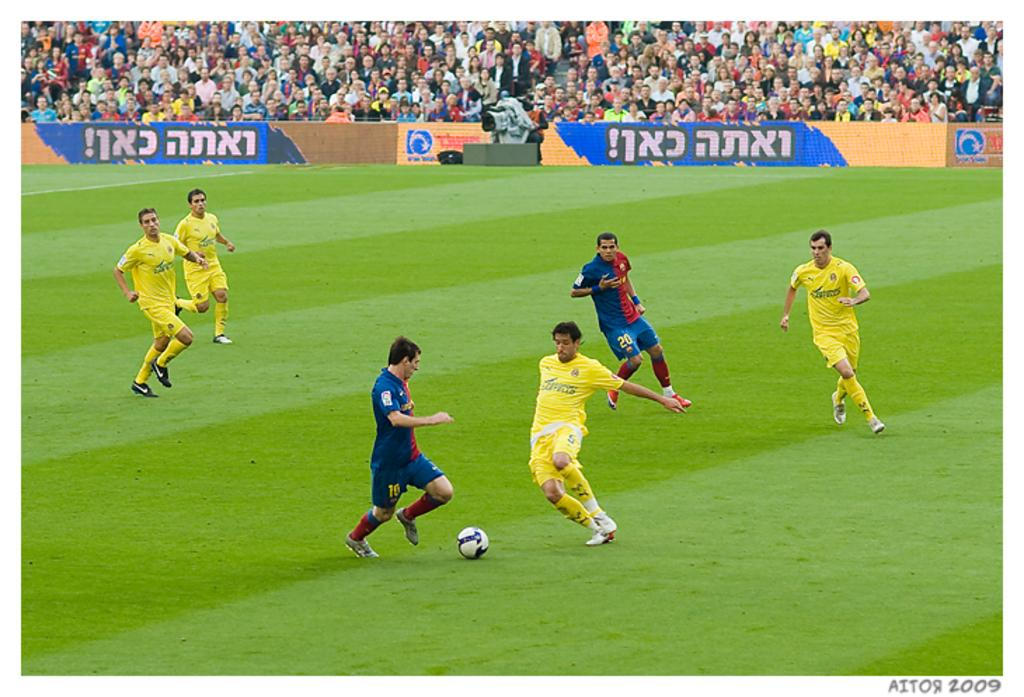<image>
Give a short and clear explanation of the subsequent image. A soccer game being played in front of banners in Hebrew. 